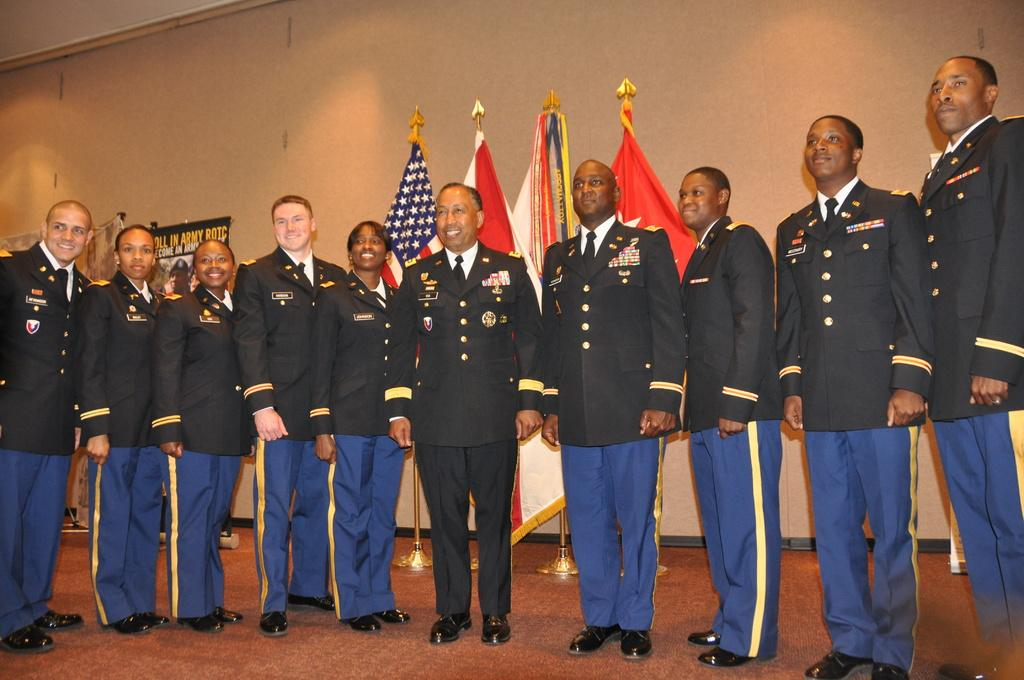How many people are in the image? There is a group of people in the image, but the exact number is not specified. What are the people doing in the image? The people are standing on the floor and smiling. What can be seen in the background of the image? There are flags visible in the image, as well as a wall. What is hanging on the wall in the image? There is a poster hanging on the wall in the image. What else can be seen in the image besides the people and the wall? There are objects visible in the image. Can you see any fog in the image? No, there is no fog present in the image. Are there any bats flying around in the image? No, there are no bats present in the image. 